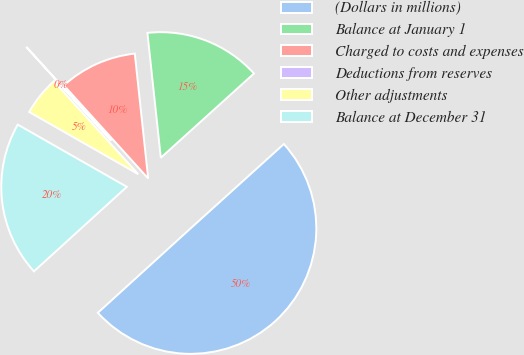Convert chart to OTSL. <chart><loc_0><loc_0><loc_500><loc_500><pie_chart><fcel>(Dollars in millions)<fcel>Balance at January 1<fcel>Charged to costs and expenses<fcel>Deductions from reserves<fcel>Other adjustments<fcel>Balance at December 31<nl><fcel>49.95%<fcel>15.0%<fcel>10.01%<fcel>0.02%<fcel>5.02%<fcel>20.0%<nl></chart> 